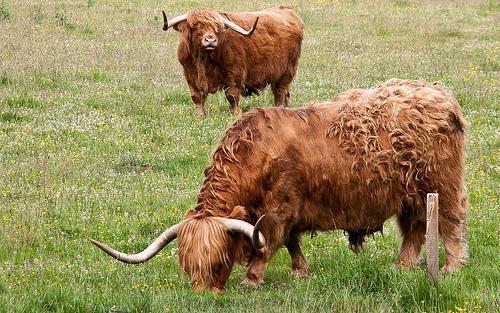How many yaks are visible?
Give a very brief answer. 2. How many horns does each yak have?
Give a very brief answer. 2. 